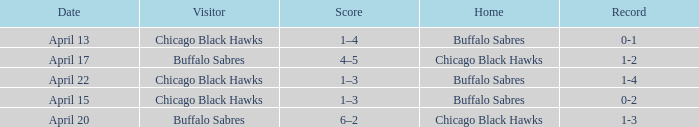Name the Visitor that has a Home of chicago black hawks on april 20? Buffalo Sabres. 